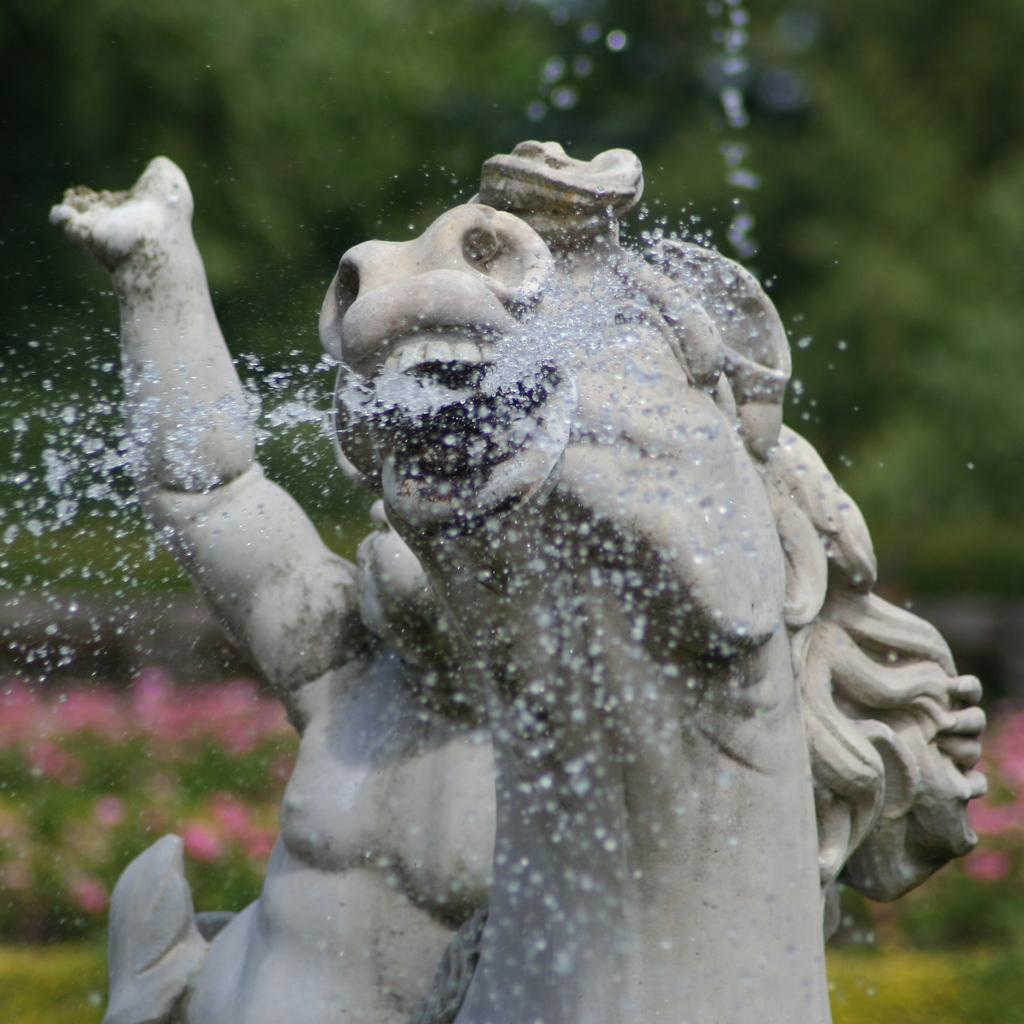What is the main feature of the sculpture in the image? Water is coming out of the sculpture in the image. What type of vegetation can be seen in the image? There are trees, plants, and flowers in the image. How is the background of the image depicted? The background of the image is blurred. How does the rice cook in the image? There is no rice present in the image, so it cannot be cooked or observed in any way. 